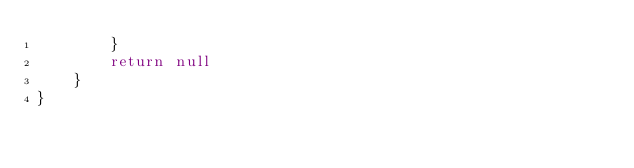Convert code to text. <code><loc_0><loc_0><loc_500><loc_500><_Kotlin_>        }
        return null
    }
}</code> 